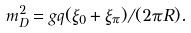<formula> <loc_0><loc_0><loc_500><loc_500>m ^ { 2 } _ { D } = g q ( \xi _ { 0 } + \xi _ { \pi } ) / ( 2 \pi R ) .</formula> 